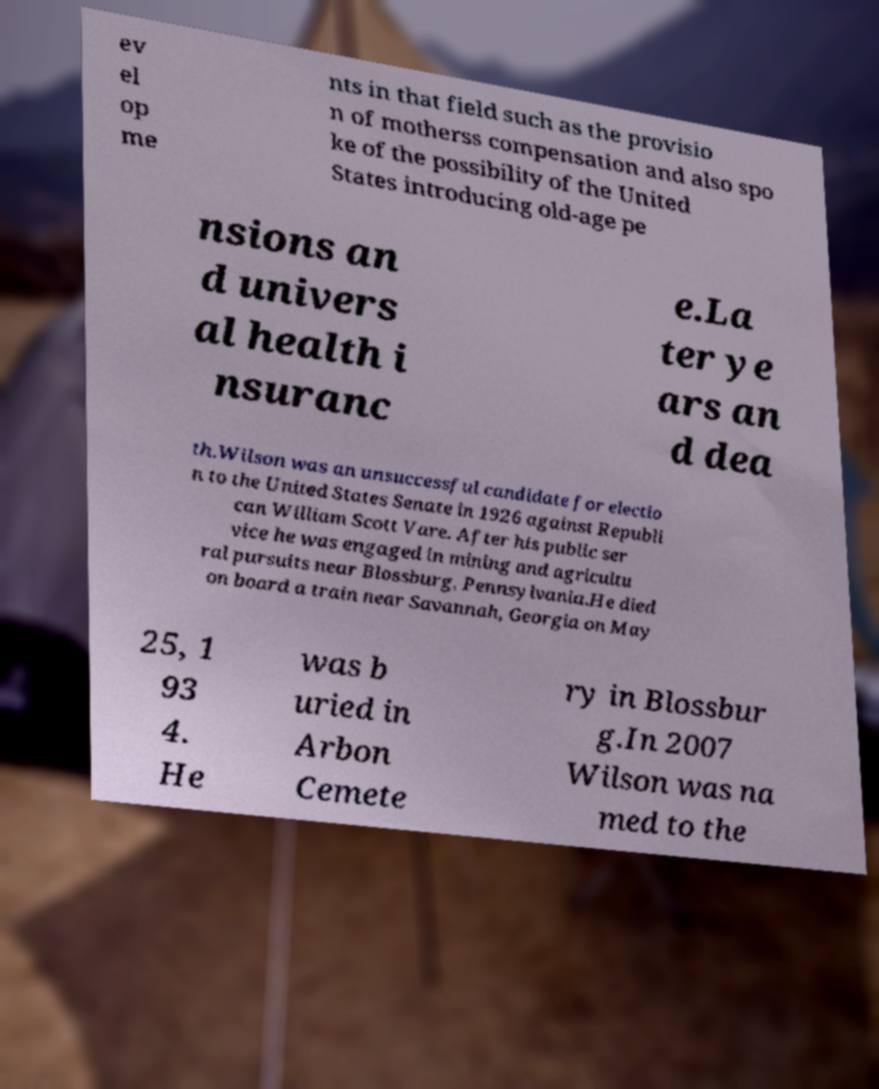I need the written content from this picture converted into text. Can you do that? ev el op me nts in that field such as the provisio n of motherss compensation and also spo ke of the possibility of the United States introducing old-age pe nsions an d univers al health i nsuranc e.La ter ye ars an d dea th.Wilson was an unsuccessful candidate for electio n to the United States Senate in 1926 against Republi can William Scott Vare. After his public ser vice he was engaged in mining and agricultu ral pursuits near Blossburg, Pennsylvania.He died on board a train near Savannah, Georgia on May 25, 1 93 4. He was b uried in Arbon Cemete ry in Blossbur g.In 2007 Wilson was na med to the 